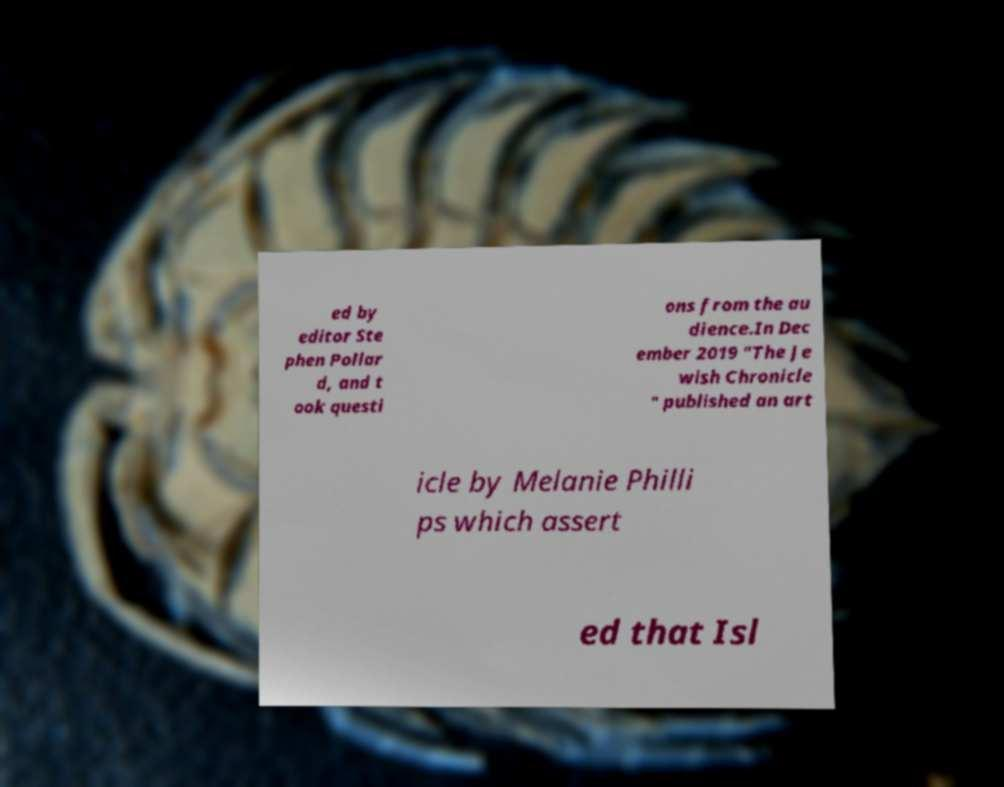Please identify and transcribe the text found in this image. ed by editor Ste phen Pollar d, and t ook questi ons from the au dience.In Dec ember 2019 "The Je wish Chronicle " published an art icle by Melanie Philli ps which assert ed that Isl 